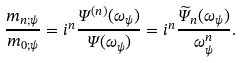Convert formula to latex. <formula><loc_0><loc_0><loc_500><loc_500>\frac { m _ { n ; \psi } } { m _ { 0 ; \psi } } = i ^ { n } \frac { \Psi ^ { ( n ) } ( \omega _ { \psi } ) } { \Psi ( \omega _ { \psi } ) } = i ^ { n } \frac { \widetilde { \Psi } _ { n } ( \omega _ { \psi } ) } { \omega _ { \psi } ^ { n } } .</formula> 